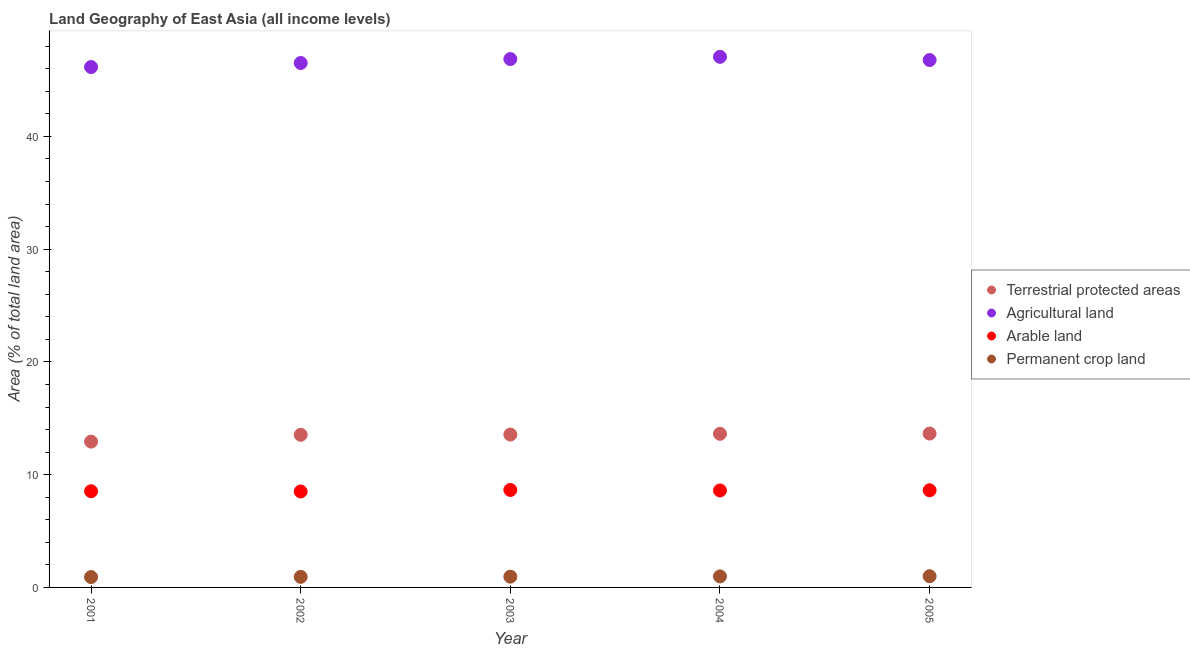How many different coloured dotlines are there?
Make the answer very short. 4. Is the number of dotlines equal to the number of legend labels?
Make the answer very short. Yes. What is the percentage of area under permanent crop land in 2005?
Make the answer very short. 1. Across all years, what is the maximum percentage of area under permanent crop land?
Make the answer very short. 1. Across all years, what is the minimum percentage of area under agricultural land?
Your answer should be very brief. 46.16. In which year was the percentage of land under terrestrial protection maximum?
Ensure brevity in your answer.  2005. What is the total percentage of area under permanent crop land in the graph?
Provide a short and direct response. 4.78. What is the difference between the percentage of area under permanent crop land in 2002 and that in 2003?
Offer a very short reply. -0.02. What is the difference between the percentage of area under arable land in 2003 and the percentage of area under permanent crop land in 2001?
Offer a terse response. 7.73. What is the average percentage of area under arable land per year?
Ensure brevity in your answer.  8.58. In the year 2002, what is the difference between the percentage of area under agricultural land and percentage of area under permanent crop land?
Your answer should be compact. 45.58. In how many years, is the percentage of area under agricultural land greater than 28 %?
Your answer should be very brief. 5. What is the ratio of the percentage of area under agricultural land in 2001 to that in 2002?
Give a very brief answer. 0.99. Is the difference between the percentage of land under terrestrial protection in 2003 and 2004 greater than the difference between the percentage of area under arable land in 2003 and 2004?
Ensure brevity in your answer.  No. What is the difference between the highest and the second highest percentage of area under agricultural land?
Offer a terse response. 0.2. What is the difference between the highest and the lowest percentage of land under terrestrial protection?
Offer a terse response. 0.71. Does the percentage of land under terrestrial protection monotonically increase over the years?
Offer a terse response. Yes. Is the percentage of area under agricultural land strictly less than the percentage of land under terrestrial protection over the years?
Give a very brief answer. No. What is the difference between two consecutive major ticks on the Y-axis?
Your answer should be compact. 10. Are the values on the major ticks of Y-axis written in scientific E-notation?
Give a very brief answer. No. Does the graph contain any zero values?
Provide a short and direct response. No. Does the graph contain grids?
Your answer should be very brief. No. Where does the legend appear in the graph?
Provide a short and direct response. Center right. How many legend labels are there?
Your response must be concise. 4. How are the legend labels stacked?
Your response must be concise. Vertical. What is the title of the graph?
Make the answer very short. Land Geography of East Asia (all income levels). What is the label or title of the X-axis?
Your answer should be compact. Year. What is the label or title of the Y-axis?
Provide a short and direct response. Area (% of total land area). What is the Area (% of total land area) of Terrestrial protected areas in 2001?
Provide a short and direct response. 12.93. What is the Area (% of total land area) of Agricultural land in 2001?
Keep it short and to the point. 46.16. What is the Area (% of total land area) in Arable land in 2001?
Provide a short and direct response. 8.53. What is the Area (% of total land area) in Permanent crop land in 2001?
Provide a succinct answer. 0.92. What is the Area (% of total land area) of Terrestrial protected areas in 2002?
Your answer should be very brief. 13.54. What is the Area (% of total land area) in Agricultural land in 2002?
Offer a very short reply. 46.52. What is the Area (% of total land area) of Arable land in 2002?
Offer a very short reply. 8.51. What is the Area (% of total land area) of Permanent crop land in 2002?
Keep it short and to the point. 0.93. What is the Area (% of total land area) in Terrestrial protected areas in 2003?
Ensure brevity in your answer.  13.56. What is the Area (% of total land area) in Agricultural land in 2003?
Offer a terse response. 46.87. What is the Area (% of total land area) of Arable land in 2003?
Give a very brief answer. 8.64. What is the Area (% of total land area) of Permanent crop land in 2003?
Offer a very short reply. 0.95. What is the Area (% of total land area) in Terrestrial protected areas in 2004?
Provide a short and direct response. 13.63. What is the Area (% of total land area) in Agricultural land in 2004?
Offer a very short reply. 47.06. What is the Area (% of total land area) of Arable land in 2004?
Provide a succinct answer. 8.6. What is the Area (% of total land area) of Permanent crop land in 2004?
Keep it short and to the point. 0.98. What is the Area (% of total land area) of Terrestrial protected areas in 2005?
Keep it short and to the point. 13.65. What is the Area (% of total land area) in Agricultural land in 2005?
Keep it short and to the point. 46.78. What is the Area (% of total land area) of Arable land in 2005?
Provide a short and direct response. 8.62. What is the Area (% of total land area) in Permanent crop land in 2005?
Give a very brief answer. 1. Across all years, what is the maximum Area (% of total land area) in Terrestrial protected areas?
Your answer should be compact. 13.65. Across all years, what is the maximum Area (% of total land area) in Agricultural land?
Give a very brief answer. 47.06. Across all years, what is the maximum Area (% of total land area) of Arable land?
Give a very brief answer. 8.64. Across all years, what is the maximum Area (% of total land area) in Permanent crop land?
Your answer should be compact. 1. Across all years, what is the minimum Area (% of total land area) of Terrestrial protected areas?
Offer a very short reply. 12.93. Across all years, what is the minimum Area (% of total land area) of Agricultural land?
Keep it short and to the point. 46.16. Across all years, what is the minimum Area (% of total land area) in Arable land?
Make the answer very short. 8.51. Across all years, what is the minimum Area (% of total land area) in Permanent crop land?
Provide a succinct answer. 0.92. What is the total Area (% of total land area) in Terrestrial protected areas in the graph?
Give a very brief answer. 67.3. What is the total Area (% of total land area) of Agricultural land in the graph?
Keep it short and to the point. 233.37. What is the total Area (% of total land area) of Arable land in the graph?
Offer a very short reply. 42.91. What is the total Area (% of total land area) of Permanent crop land in the graph?
Your answer should be compact. 4.78. What is the difference between the Area (% of total land area) in Terrestrial protected areas in 2001 and that in 2002?
Offer a very short reply. -0.6. What is the difference between the Area (% of total land area) in Agricultural land in 2001 and that in 2002?
Your answer should be very brief. -0.36. What is the difference between the Area (% of total land area) in Arable land in 2001 and that in 2002?
Your answer should be compact. 0.02. What is the difference between the Area (% of total land area) in Permanent crop land in 2001 and that in 2002?
Give a very brief answer. -0.02. What is the difference between the Area (% of total land area) of Terrestrial protected areas in 2001 and that in 2003?
Provide a succinct answer. -0.62. What is the difference between the Area (% of total land area) in Agricultural land in 2001 and that in 2003?
Keep it short and to the point. -0.71. What is the difference between the Area (% of total land area) in Arable land in 2001 and that in 2003?
Give a very brief answer. -0.11. What is the difference between the Area (% of total land area) in Permanent crop land in 2001 and that in 2003?
Give a very brief answer. -0.03. What is the difference between the Area (% of total land area) in Terrestrial protected areas in 2001 and that in 2004?
Your answer should be very brief. -0.69. What is the difference between the Area (% of total land area) in Agricultural land in 2001 and that in 2004?
Ensure brevity in your answer.  -0.91. What is the difference between the Area (% of total land area) in Arable land in 2001 and that in 2004?
Ensure brevity in your answer.  -0.07. What is the difference between the Area (% of total land area) in Permanent crop land in 2001 and that in 2004?
Your answer should be compact. -0.06. What is the difference between the Area (% of total land area) of Terrestrial protected areas in 2001 and that in 2005?
Your answer should be compact. -0.71. What is the difference between the Area (% of total land area) in Agricultural land in 2001 and that in 2005?
Provide a succinct answer. -0.62. What is the difference between the Area (% of total land area) of Arable land in 2001 and that in 2005?
Ensure brevity in your answer.  -0.09. What is the difference between the Area (% of total land area) of Permanent crop land in 2001 and that in 2005?
Provide a succinct answer. -0.08. What is the difference between the Area (% of total land area) of Terrestrial protected areas in 2002 and that in 2003?
Ensure brevity in your answer.  -0.02. What is the difference between the Area (% of total land area) in Agricultural land in 2002 and that in 2003?
Offer a terse response. -0.35. What is the difference between the Area (% of total land area) in Arable land in 2002 and that in 2003?
Keep it short and to the point. -0.13. What is the difference between the Area (% of total land area) in Permanent crop land in 2002 and that in 2003?
Keep it short and to the point. -0.02. What is the difference between the Area (% of total land area) in Terrestrial protected areas in 2002 and that in 2004?
Provide a succinct answer. -0.09. What is the difference between the Area (% of total land area) of Agricultural land in 2002 and that in 2004?
Ensure brevity in your answer.  -0.55. What is the difference between the Area (% of total land area) in Arable land in 2002 and that in 2004?
Provide a short and direct response. -0.09. What is the difference between the Area (% of total land area) in Permanent crop land in 2002 and that in 2004?
Ensure brevity in your answer.  -0.04. What is the difference between the Area (% of total land area) of Terrestrial protected areas in 2002 and that in 2005?
Make the answer very short. -0.11. What is the difference between the Area (% of total land area) of Agricultural land in 2002 and that in 2005?
Provide a short and direct response. -0.26. What is the difference between the Area (% of total land area) of Arable land in 2002 and that in 2005?
Offer a terse response. -0.11. What is the difference between the Area (% of total land area) in Permanent crop land in 2002 and that in 2005?
Provide a short and direct response. -0.06. What is the difference between the Area (% of total land area) in Terrestrial protected areas in 2003 and that in 2004?
Provide a short and direct response. -0.07. What is the difference between the Area (% of total land area) of Agricultural land in 2003 and that in 2004?
Give a very brief answer. -0.2. What is the difference between the Area (% of total land area) in Arable land in 2003 and that in 2004?
Your response must be concise. 0.04. What is the difference between the Area (% of total land area) in Permanent crop land in 2003 and that in 2004?
Provide a short and direct response. -0.02. What is the difference between the Area (% of total land area) of Terrestrial protected areas in 2003 and that in 2005?
Ensure brevity in your answer.  -0.09. What is the difference between the Area (% of total land area) of Agricultural land in 2003 and that in 2005?
Keep it short and to the point. 0.09. What is the difference between the Area (% of total land area) of Arable land in 2003 and that in 2005?
Your response must be concise. 0.03. What is the difference between the Area (% of total land area) of Permanent crop land in 2003 and that in 2005?
Your response must be concise. -0.04. What is the difference between the Area (% of total land area) of Terrestrial protected areas in 2004 and that in 2005?
Provide a short and direct response. -0.02. What is the difference between the Area (% of total land area) of Agricultural land in 2004 and that in 2005?
Provide a succinct answer. 0.28. What is the difference between the Area (% of total land area) of Arable land in 2004 and that in 2005?
Offer a very short reply. -0.02. What is the difference between the Area (% of total land area) in Permanent crop land in 2004 and that in 2005?
Offer a terse response. -0.02. What is the difference between the Area (% of total land area) in Terrestrial protected areas in 2001 and the Area (% of total land area) in Agricultural land in 2002?
Offer a very short reply. -33.58. What is the difference between the Area (% of total land area) of Terrestrial protected areas in 2001 and the Area (% of total land area) of Arable land in 2002?
Your response must be concise. 4.42. What is the difference between the Area (% of total land area) of Terrestrial protected areas in 2001 and the Area (% of total land area) of Permanent crop land in 2002?
Offer a terse response. 12. What is the difference between the Area (% of total land area) in Agricultural land in 2001 and the Area (% of total land area) in Arable land in 2002?
Provide a short and direct response. 37.64. What is the difference between the Area (% of total land area) of Agricultural land in 2001 and the Area (% of total land area) of Permanent crop land in 2002?
Offer a very short reply. 45.22. What is the difference between the Area (% of total land area) in Arable land in 2001 and the Area (% of total land area) in Permanent crop land in 2002?
Give a very brief answer. 7.6. What is the difference between the Area (% of total land area) in Terrestrial protected areas in 2001 and the Area (% of total land area) in Agricultural land in 2003?
Offer a terse response. -33.93. What is the difference between the Area (% of total land area) in Terrestrial protected areas in 2001 and the Area (% of total land area) in Arable land in 2003?
Provide a short and direct response. 4.29. What is the difference between the Area (% of total land area) of Terrestrial protected areas in 2001 and the Area (% of total land area) of Permanent crop land in 2003?
Keep it short and to the point. 11.98. What is the difference between the Area (% of total land area) of Agricultural land in 2001 and the Area (% of total land area) of Arable land in 2003?
Give a very brief answer. 37.51. What is the difference between the Area (% of total land area) of Agricultural land in 2001 and the Area (% of total land area) of Permanent crop land in 2003?
Ensure brevity in your answer.  45.2. What is the difference between the Area (% of total land area) of Arable land in 2001 and the Area (% of total land area) of Permanent crop land in 2003?
Offer a terse response. 7.58. What is the difference between the Area (% of total land area) of Terrestrial protected areas in 2001 and the Area (% of total land area) of Agricultural land in 2004?
Offer a very short reply. -34.13. What is the difference between the Area (% of total land area) in Terrestrial protected areas in 2001 and the Area (% of total land area) in Arable land in 2004?
Keep it short and to the point. 4.33. What is the difference between the Area (% of total land area) in Terrestrial protected areas in 2001 and the Area (% of total land area) in Permanent crop land in 2004?
Your answer should be very brief. 11.96. What is the difference between the Area (% of total land area) of Agricultural land in 2001 and the Area (% of total land area) of Arable land in 2004?
Your response must be concise. 37.55. What is the difference between the Area (% of total land area) in Agricultural land in 2001 and the Area (% of total land area) in Permanent crop land in 2004?
Make the answer very short. 45.18. What is the difference between the Area (% of total land area) in Arable land in 2001 and the Area (% of total land area) in Permanent crop land in 2004?
Provide a succinct answer. 7.55. What is the difference between the Area (% of total land area) of Terrestrial protected areas in 2001 and the Area (% of total land area) of Agricultural land in 2005?
Offer a terse response. -33.84. What is the difference between the Area (% of total land area) in Terrestrial protected areas in 2001 and the Area (% of total land area) in Arable land in 2005?
Give a very brief answer. 4.32. What is the difference between the Area (% of total land area) of Terrestrial protected areas in 2001 and the Area (% of total land area) of Permanent crop land in 2005?
Provide a short and direct response. 11.94. What is the difference between the Area (% of total land area) of Agricultural land in 2001 and the Area (% of total land area) of Arable land in 2005?
Provide a short and direct response. 37.54. What is the difference between the Area (% of total land area) of Agricultural land in 2001 and the Area (% of total land area) of Permanent crop land in 2005?
Make the answer very short. 45.16. What is the difference between the Area (% of total land area) in Arable land in 2001 and the Area (% of total land area) in Permanent crop land in 2005?
Keep it short and to the point. 7.54. What is the difference between the Area (% of total land area) in Terrestrial protected areas in 2002 and the Area (% of total land area) in Agricultural land in 2003?
Give a very brief answer. -33.33. What is the difference between the Area (% of total land area) in Terrestrial protected areas in 2002 and the Area (% of total land area) in Arable land in 2003?
Make the answer very short. 4.89. What is the difference between the Area (% of total land area) of Terrestrial protected areas in 2002 and the Area (% of total land area) of Permanent crop land in 2003?
Your answer should be very brief. 12.58. What is the difference between the Area (% of total land area) of Agricultural land in 2002 and the Area (% of total land area) of Arable land in 2003?
Keep it short and to the point. 37.87. What is the difference between the Area (% of total land area) of Agricultural land in 2002 and the Area (% of total land area) of Permanent crop land in 2003?
Your response must be concise. 45.56. What is the difference between the Area (% of total land area) of Arable land in 2002 and the Area (% of total land area) of Permanent crop land in 2003?
Keep it short and to the point. 7.56. What is the difference between the Area (% of total land area) of Terrestrial protected areas in 2002 and the Area (% of total land area) of Agricultural land in 2004?
Offer a very short reply. -33.52. What is the difference between the Area (% of total land area) of Terrestrial protected areas in 2002 and the Area (% of total land area) of Arable land in 2004?
Offer a terse response. 4.94. What is the difference between the Area (% of total land area) in Terrestrial protected areas in 2002 and the Area (% of total land area) in Permanent crop land in 2004?
Your response must be concise. 12.56. What is the difference between the Area (% of total land area) of Agricultural land in 2002 and the Area (% of total land area) of Arable land in 2004?
Your response must be concise. 37.91. What is the difference between the Area (% of total land area) of Agricultural land in 2002 and the Area (% of total land area) of Permanent crop land in 2004?
Make the answer very short. 45.54. What is the difference between the Area (% of total land area) in Arable land in 2002 and the Area (% of total land area) in Permanent crop land in 2004?
Offer a very short reply. 7.53. What is the difference between the Area (% of total land area) in Terrestrial protected areas in 2002 and the Area (% of total land area) in Agricultural land in 2005?
Provide a succinct answer. -33.24. What is the difference between the Area (% of total land area) of Terrestrial protected areas in 2002 and the Area (% of total land area) of Arable land in 2005?
Provide a short and direct response. 4.92. What is the difference between the Area (% of total land area) in Terrestrial protected areas in 2002 and the Area (% of total land area) in Permanent crop land in 2005?
Give a very brief answer. 12.54. What is the difference between the Area (% of total land area) in Agricultural land in 2002 and the Area (% of total land area) in Arable land in 2005?
Provide a succinct answer. 37.9. What is the difference between the Area (% of total land area) of Agricultural land in 2002 and the Area (% of total land area) of Permanent crop land in 2005?
Provide a short and direct response. 45.52. What is the difference between the Area (% of total land area) of Arable land in 2002 and the Area (% of total land area) of Permanent crop land in 2005?
Your response must be concise. 7.52. What is the difference between the Area (% of total land area) of Terrestrial protected areas in 2003 and the Area (% of total land area) of Agricultural land in 2004?
Give a very brief answer. -33.5. What is the difference between the Area (% of total land area) in Terrestrial protected areas in 2003 and the Area (% of total land area) in Arable land in 2004?
Provide a short and direct response. 4.96. What is the difference between the Area (% of total land area) in Terrestrial protected areas in 2003 and the Area (% of total land area) in Permanent crop land in 2004?
Make the answer very short. 12.58. What is the difference between the Area (% of total land area) in Agricultural land in 2003 and the Area (% of total land area) in Arable land in 2004?
Keep it short and to the point. 38.27. What is the difference between the Area (% of total land area) in Agricultural land in 2003 and the Area (% of total land area) in Permanent crop land in 2004?
Your answer should be very brief. 45.89. What is the difference between the Area (% of total land area) in Arable land in 2003 and the Area (% of total land area) in Permanent crop land in 2004?
Keep it short and to the point. 7.67. What is the difference between the Area (% of total land area) of Terrestrial protected areas in 2003 and the Area (% of total land area) of Agricultural land in 2005?
Your answer should be very brief. -33.22. What is the difference between the Area (% of total land area) in Terrestrial protected areas in 2003 and the Area (% of total land area) in Arable land in 2005?
Keep it short and to the point. 4.94. What is the difference between the Area (% of total land area) of Terrestrial protected areas in 2003 and the Area (% of total land area) of Permanent crop land in 2005?
Ensure brevity in your answer.  12.56. What is the difference between the Area (% of total land area) of Agricultural land in 2003 and the Area (% of total land area) of Arable land in 2005?
Provide a short and direct response. 38.25. What is the difference between the Area (% of total land area) in Agricultural land in 2003 and the Area (% of total land area) in Permanent crop land in 2005?
Make the answer very short. 45.87. What is the difference between the Area (% of total land area) in Arable land in 2003 and the Area (% of total land area) in Permanent crop land in 2005?
Keep it short and to the point. 7.65. What is the difference between the Area (% of total land area) of Terrestrial protected areas in 2004 and the Area (% of total land area) of Agricultural land in 2005?
Ensure brevity in your answer.  -33.15. What is the difference between the Area (% of total land area) of Terrestrial protected areas in 2004 and the Area (% of total land area) of Arable land in 2005?
Give a very brief answer. 5.01. What is the difference between the Area (% of total land area) in Terrestrial protected areas in 2004 and the Area (% of total land area) in Permanent crop land in 2005?
Provide a succinct answer. 12.63. What is the difference between the Area (% of total land area) in Agricultural land in 2004 and the Area (% of total land area) in Arable land in 2005?
Keep it short and to the point. 38.44. What is the difference between the Area (% of total land area) of Agricultural land in 2004 and the Area (% of total land area) of Permanent crop land in 2005?
Offer a very short reply. 46.07. What is the difference between the Area (% of total land area) of Arable land in 2004 and the Area (% of total land area) of Permanent crop land in 2005?
Give a very brief answer. 7.61. What is the average Area (% of total land area) of Terrestrial protected areas per year?
Give a very brief answer. 13.46. What is the average Area (% of total land area) of Agricultural land per year?
Give a very brief answer. 46.67. What is the average Area (% of total land area) of Arable land per year?
Your answer should be compact. 8.58. What is the average Area (% of total land area) in Permanent crop land per year?
Keep it short and to the point. 0.96. In the year 2001, what is the difference between the Area (% of total land area) of Terrestrial protected areas and Area (% of total land area) of Agricultural land?
Offer a terse response. -33.22. In the year 2001, what is the difference between the Area (% of total land area) of Terrestrial protected areas and Area (% of total land area) of Arable land?
Keep it short and to the point. 4.4. In the year 2001, what is the difference between the Area (% of total land area) of Terrestrial protected areas and Area (% of total land area) of Permanent crop land?
Offer a very short reply. 12.02. In the year 2001, what is the difference between the Area (% of total land area) in Agricultural land and Area (% of total land area) in Arable land?
Your answer should be compact. 37.62. In the year 2001, what is the difference between the Area (% of total land area) of Agricultural land and Area (% of total land area) of Permanent crop land?
Offer a terse response. 45.24. In the year 2001, what is the difference between the Area (% of total land area) of Arable land and Area (% of total land area) of Permanent crop land?
Provide a short and direct response. 7.61. In the year 2002, what is the difference between the Area (% of total land area) in Terrestrial protected areas and Area (% of total land area) in Agricultural land?
Provide a short and direct response. -32.98. In the year 2002, what is the difference between the Area (% of total land area) of Terrestrial protected areas and Area (% of total land area) of Arable land?
Keep it short and to the point. 5.03. In the year 2002, what is the difference between the Area (% of total land area) in Terrestrial protected areas and Area (% of total land area) in Permanent crop land?
Make the answer very short. 12.6. In the year 2002, what is the difference between the Area (% of total land area) of Agricultural land and Area (% of total land area) of Arable land?
Your response must be concise. 38. In the year 2002, what is the difference between the Area (% of total land area) of Agricultural land and Area (% of total land area) of Permanent crop land?
Your answer should be very brief. 45.58. In the year 2002, what is the difference between the Area (% of total land area) in Arable land and Area (% of total land area) in Permanent crop land?
Provide a short and direct response. 7.58. In the year 2003, what is the difference between the Area (% of total land area) in Terrestrial protected areas and Area (% of total land area) in Agricultural land?
Offer a terse response. -33.31. In the year 2003, what is the difference between the Area (% of total land area) in Terrestrial protected areas and Area (% of total land area) in Arable land?
Offer a very short reply. 4.91. In the year 2003, what is the difference between the Area (% of total land area) of Terrestrial protected areas and Area (% of total land area) of Permanent crop land?
Your answer should be compact. 12.6. In the year 2003, what is the difference between the Area (% of total land area) of Agricultural land and Area (% of total land area) of Arable land?
Give a very brief answer. 38.22. In the year 2003, what is the difference between the Area (% of total land area) of Agricultural land and Area (% of total land area) of Permanent crop land?
Give a very brief answer. 45.91. In the year 2003, what is the difference between the Area (% of total land area) of Arable land and Area (% of total land area) of Permanent crop land?
Offer a very short reply. 7.69. In the year 2004, what is the difference between the Area (% of total land area) in Terrestrial protected areas and Area (% of total land area) in Agricultural land?
Provide a succinct answer. -33.43. In the year 2004, what is the difference between the Area (% of total land area) in Terrestrial protected areas and Area (% of total land area) in Arable land?
Your answer should be very brief. 5.03. In the year 2004, what is the difference between the Area (% of total land area) of Terrestrial protected areas and Area (% of total land area) of Permanent crop land?
Your answer should be very brief. 12.65. In the year 2004, what is the difference between the Area (% of total land area) of Agricultural land and Area (% of total land area) of Arable land?
Keep it short and to the point. 38.46. In the year 2004, what is the difference between the Area (% of total land area) in Agricultural land and Area (% of total land area) in Permanent crop land?
Make the answer very short. 46.08. In the year 2004, what is the difference between the Area (% of total land area) in Arable land and Area (% of total land area) in Permanent crop land?
Provide a succinct answer. 7.62. In the year 2005, what is the difference between the Area (% of total land area) in Terrestrial protected areas and Area (% of total land area) in Agricultural land?
Your response must be concise. -33.13. In the year 2005, what is the difference between the Area (% of total land area) in Terrestrial protected areas and Area (% of total land area) in Arable land?
Give a very brief answer. 5.03. In the year 2005, what is the difference between the Area (% of total land area) of Terrestrial protected areas and Area (% of total land area) of Permanent crop land?
Ensure brevity in your answer.  12.65. In the year 2005, what is the difference between the Area (% of total land area) in Agricultural land and Area (% of total land area) in Arable land?
Your answer should be very brief. 38.16. In the year 2005, what is the difference between the Area (% of total land area) in Agricultural land and Area (% of total land area) in Permanent crop land?
Your answer should be very brief. 45.78. In the year 2005, what is the difference between the Area (% of total land area) of Arable land and Area (% of total land area) of Permanent crop land?
Offer a terse response. 7.62. What is the ratio of the Area (% of total land area) in Terrestrial protected areas in 2001 to that in 2002?
Make the answer very short. 0.96. What is the ratio of the Area (% of total land area) of Permanent crop land in 2001 to that in 2002?
Your answer should be compact. 0.98. What is the ratio of the Area (% of total land area) of Terrestrial protected areas in 2001 to that in 2003?
Your answer should be very brief. 0.95. What is the ratio of the Area (% of total land area) in Agricultural land in 2001 to that in 2003?
Provide a succinct answer. 0.98. What is the ratio of the Area (% of total land area) of Arable land in 2001 to that in 2003?
Provide a short and direct response. 0.99. What is the ratio of the Area (% of total land area) of Permanent crop land in 2001 to that in 2003?
Your response must be concise. 0.96. What is the ratio of the Area (% of total land area) in Terrestrial protected areas in 2001 to that in 2004?
Make the answer very short. 0.95. What is the ratio of the Area (% of total land area) of Agricultural land in 2001 to that in 2004?
Offer a terse response. 0.98. What is the ratio of the Area (% of total land area) in Permanent crop land in 2001 to that in 2004?
Your response must be concise. 0.94. What is the ratio of the Area (% of total land area) in Terrestrial protected areas in 2001 to that in 2005?
Make the answer very short. 0.95. What is the ratio of the Area (% of total land area) of Agricultural land in 2001 to that in 2005?
Offer a very short reply. 0.99. What is the ratio of the Area (% of total land area) in Permanent crop land in 2001 to that in 2005?
Your response must be concise. 0.92. What is the ratio of the Area (% of total land area) in Agricultural land in 2002 to that in 2003?
Your response must be concise. 0.99. What is the ratio of the Area (% of total land area) in Arable land in 2002 to that in 2003?
Provide a short and direct response. 0.98. What is the ratio of the Area (% of total land area) in Permanent crop land in 2002 to that in 2003?
Your answer should be very brief. 0.98. What is the ratio of the Area (% of total land area) of Agricultural land in 2002 to that in 2004?
Make the answer very short. 0.99. What is the ratio of the Area (% of total land area) in Permanent crop land in 2002 to that in 2004?
Your answer should be compact. 0.96. What is the ratio of the Area (% of total land area) in Terrestrial protected areas in 2002 to that in 2005?
Offer a terse response. 0.99. What is the ratio of the Area (% of total land area) in Agricultural land in 2002 to that in 2005?
Offer a very short reply. 0.99. What is the ratio of the Area (% of total land area) of Arable land in 2002 to that in 2005?
Give a very brief answer. 0.99. What is the ratio of the Area (% of total land area) in Permanent crop land in 2002 to that in 2005?
Ensure brevity in your answer.  0.94. What is the ratio of the Area (% of total land area) in Arable land in 2003 to that in 2004?
Provide a short and direct response. 1.01. What is the ratio of the Area (% of total land area) of Permanent crop land in 2003 to that in 2004?
Offer a terse response. 0.98. What is the ratio of the Area (% of total land area) of Terrestrial protected areas in 2003 to that in 2005?
Offer a terse response. 0.99. What is the ratio of the Area (% of total land area) in Arable land in 2003 to that in 2005?
Ensure brevity in your answer.  1. What is the ratio of the Area (% of total land area) of Permanent crop land in 2003 to that in 2005?
Give a very brief answer. 0.96. What is the ratio of the Area (% of total land area) in Agricultural land in 2004 to that in 2005?
Your answer should be very brief. 1.01. What is the ratio of the Area (% of total land area) of Permanent crop land in 2004 to that in 2005?
Your answer should be very brief. 0.98. What is the difference between the highest and the second highest Area (% of total land area) in Terrestrial protected areas?
Your answer should be compact. 0.02. What is the difference between the highest and the second highest Area (% of total land area) of Agricultural land?
Provide a short and direct response. 0.2. What is the difference between the highest and the second highest Area (% of total land area) of Arable land?
Make the answer very short. 0.03. What is the difference between the highest and the second highest Area (% of total land area) in Permanent crop land?
Your response must be concise. 0.02. What is the difference between the highest and the lowest Area (% of total land area) in Terrestrial protected areas?
Keep it short and to the point. 0.71. What is the difference between the highest and the lowest Area (% of total land area) of Agricultural land?
Offer a very short reply. 0.91. What is the difference between the highest and the lowest Area (% of total land area) in Arable land?
Your answer should be compact. 0.13. What is the difference between the highest and the lowest Area (% of total land area) of Permanent crop land?
Provide a succinct answer. 0.08. 